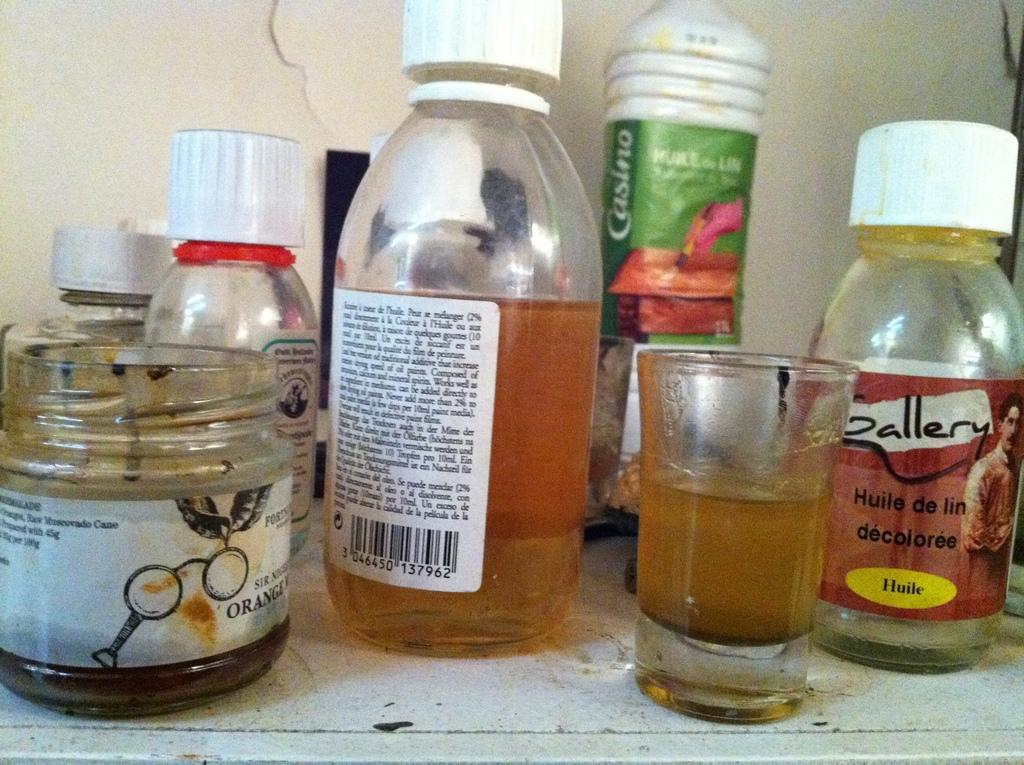<image>
Share a concise interpretation of the image provided. A bottle with the word gallery on it can be seen by other bottles. 